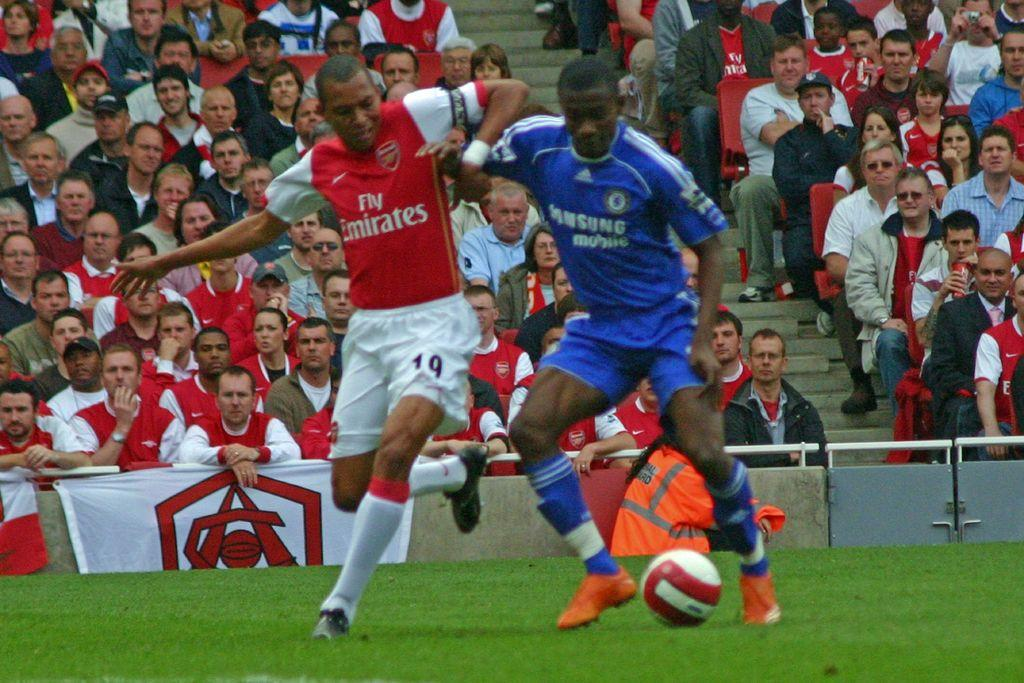<image>
Describe the image concisely. A soccer player in a Fly Emirates jersey tries to get the ball from a player in a Samsung jersey. 